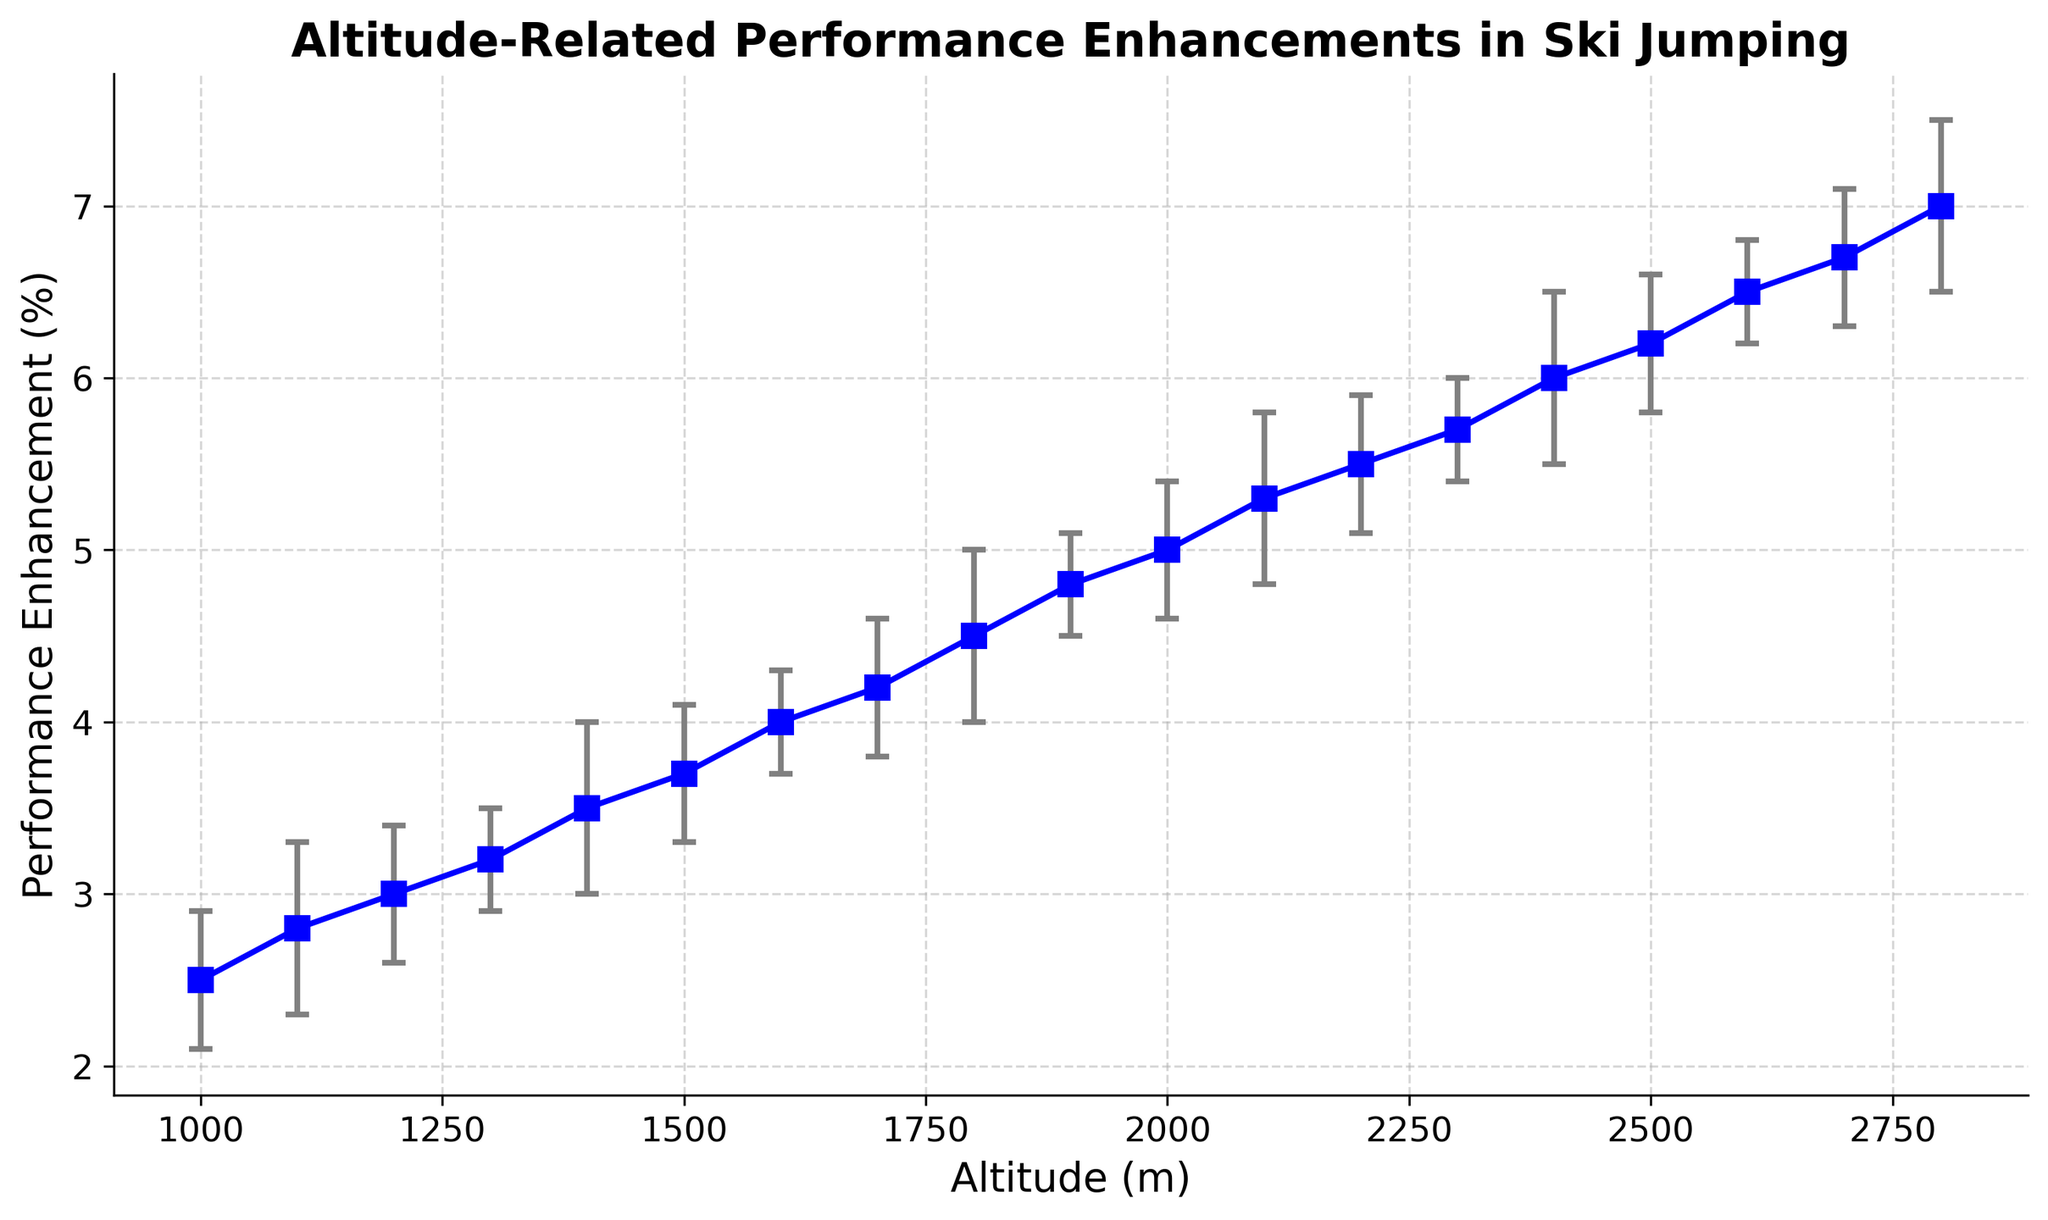How does performance enhancement change from 2005 to 2023? To determine the change in performance enhancement from 2005 to 2023, check the performance enhancement (%) values for both years. In 2005, the performance enhancement is 2.5%, and in 2023, it is 7.0%. The change is calculated by subtracting the 2005 value from the 2023 value: 7.0% - 2.5% = 4.5%.
Answer: 4.5% Which year shows the highest performance enhancement and what is the value? To identify the year with the highest performance enhancement, look at all the performance enhancement (%) values across the years. The highest value (7.0%) is observed in 2023.
Answer: 2023, 7.0% Is there a year where the error margin exceeds 0.4%? To answer this, examine the Error Margin (%) values for each year. Years with error margins exceeding 0.4% are 2006, 2009, 2013, 2016, 2019, and 2023, where the error margin is 0.5%.
Answer: Yes What is the average performance enhancement for altitudes of 1500m, 2000m, and 2500m? First, find the performance enhancement values for altitudes 1500m, 2000m, and 2500m, which are 3.7%, 5.0%, and 6.2%, respectively. Then, calculate the average: (3.7% + 5.0% + 6.2%) / 3 = 4.97%.
Answer: 4.97% Compare the performance enhancement (%) and error margin (%) for the years 2011 and 2021. What can you deduce? For 2011, performance enhancement is 4.0%, and error margin is 0.3%. For 2021, performance enhancement is 6.5%, and error margin is also 0.3%. Both years have the same error margin, but the performance enhancement increased by 2.5% from 2011 to 2021.
Answer: Performance enhancement increased by 2.5%, while error margins remained the same Given the trend in the plot, predict the performance enhancement at an altitude of 2900m. Observing the trend of increasing performance enhancement with altitude, for an altitude of 2900m (just 100m higher than the last data point), the performance enhancement would likely continue to increase. From 2800m (7.0%), a reasonable estimate would be around 7.2% to 7.3%.
Answer: 7.2% to 7.3% In which year could you observe the smallest error margin, and what was its value? Identify the smallest value in the Error Margin (%) column. The smallest error margin is 0.3%, observed in the years 2008, 2011, 2014, 2018, and 2021.
Answer: 2008, 2011, 2014, 2018, 2021; 0.3% How does the performance enhancement in 2007 compare to 2017? For 2007, the performance enhancement is 3.0%, and for 2017, it’s 5.5%. The performance enhancement in 2017 is higher by 2.5% compared to 2007.
Answer: 2017 is higher by 2.5% Evaluate the overall trend of performance enhancement with increasing altitude. Does the performance enhancement generally increase, decrease, or stay the same? By observing the performance enhancement (%) values across increasing altitudes, the trend clearly shows a general increase in performance enhancement as altitude goes up from 1000m to 2800m.
Answer: Increase 